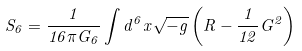<formula> <loc_0><loc_0><loc_500><loc_500>S _ { 6 } = \frac { 1 } { 1 6 \pi G _ { 6 } } \int { d ^ { 6 } x \sqrt { - g } \left ( R - \frac { 1 } { 1 2 } G ^ { 2 } \right ) }</formula> 